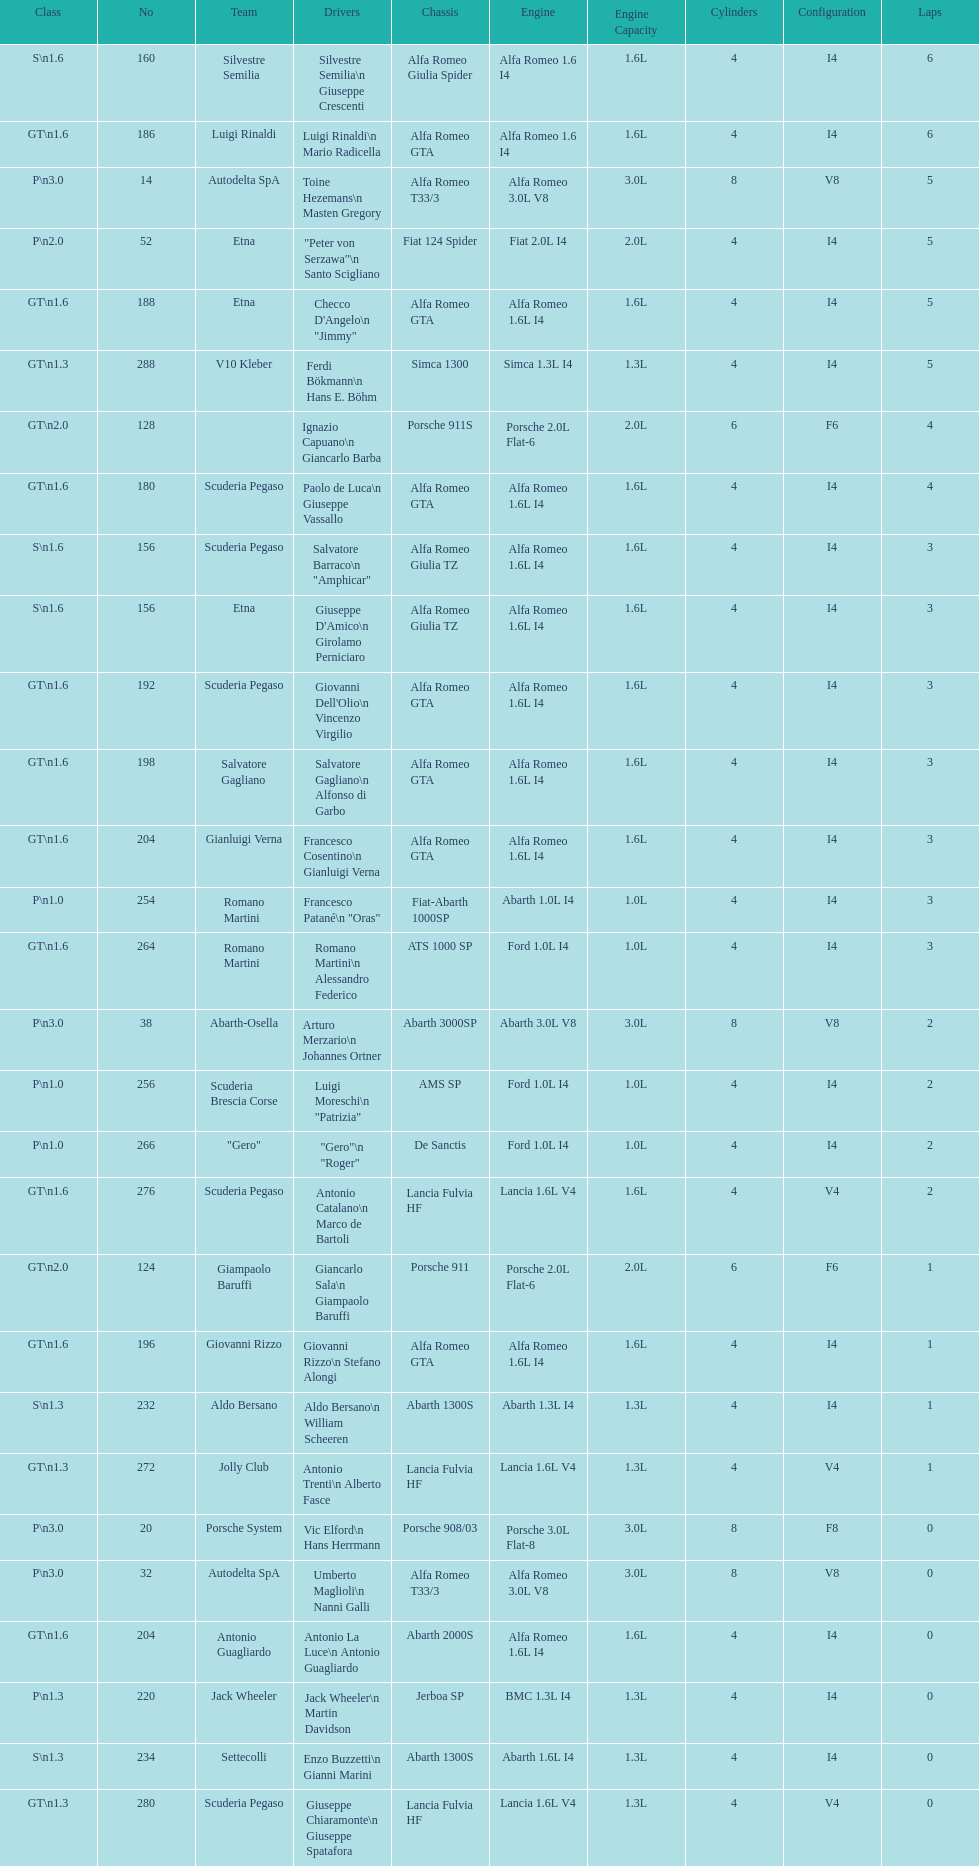What class is below s 1.6? GT 1.6. 